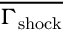Convert formula to latex. <formula><loc_0><loc_0><loc_500><loc_500>\overline { { \Gamma _ { s h o c k } } }</formula> 